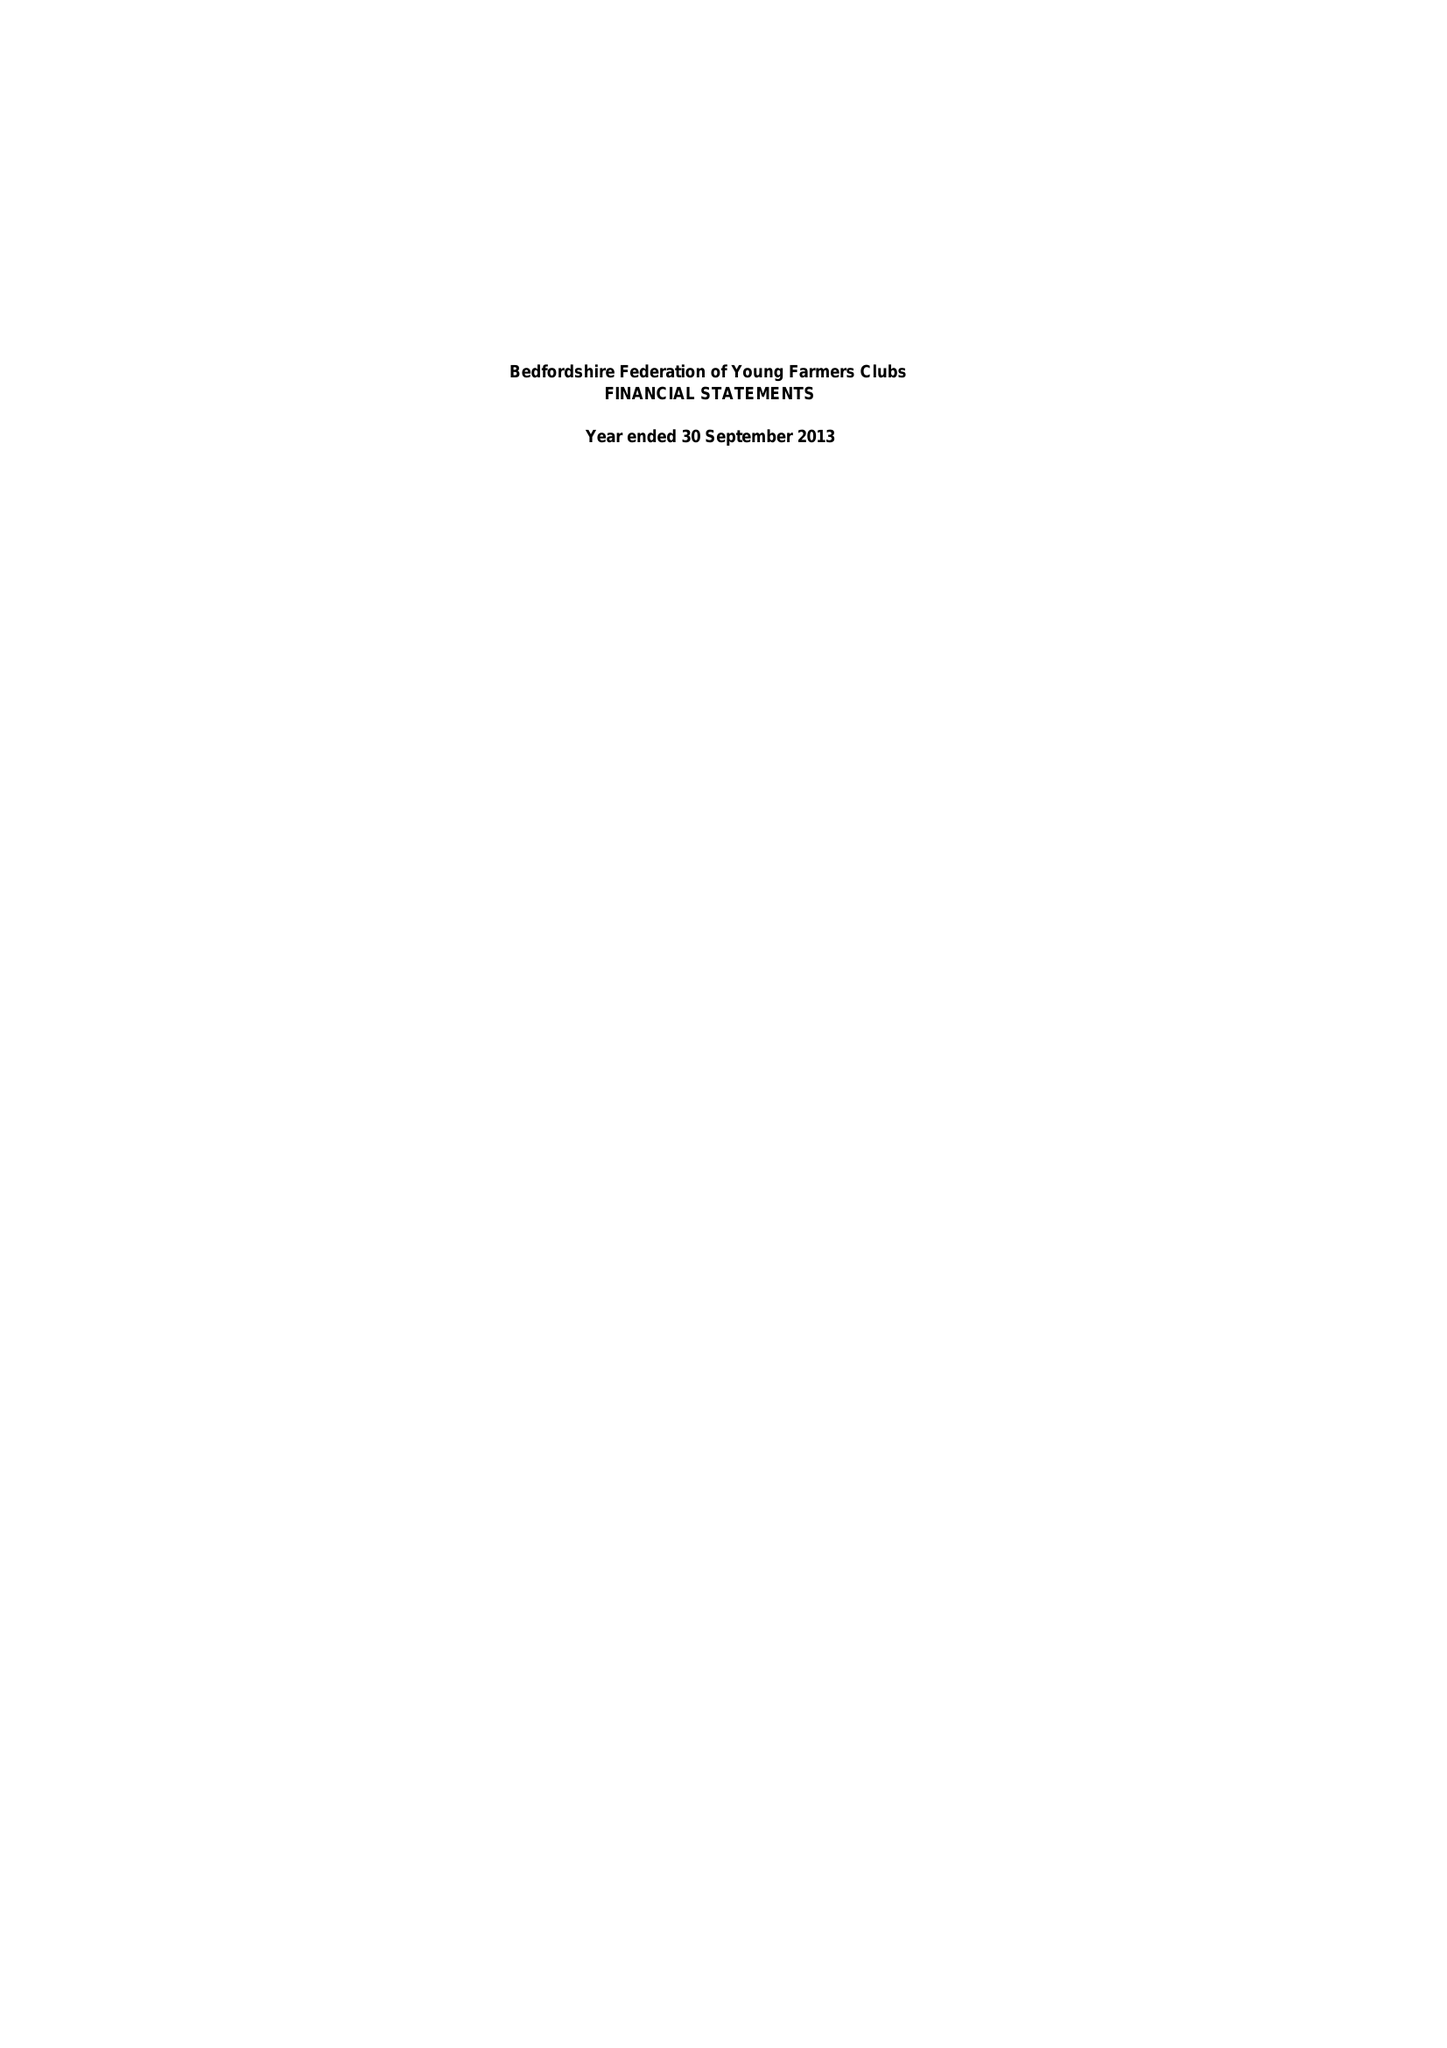What is the value for the address__postcode?
Answer the question using a single word or phrase. None 